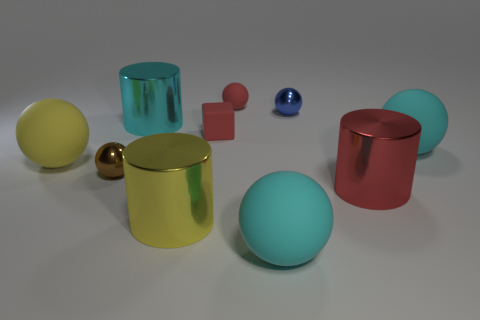What material is the cylinder that is the same color as the tiny matte ball?
Provide a short and direct response. Metal. There is a metal sphere that is right of the tiny shiny thing that is on the left side of the big matte ball that is in front of the large yellow rubber ball; what size is it?
Your response must be concise. Small. What number of blue cubes have the same material as the small brown thing?
Provide a short and direct response. 0. Are there fewer small cubes than cyan objects?
Your response must be concise. Yes. There is a blue metal object that is the same shape as the big yellow rubber thing; what is its size?
Provide a succinct answer. Small. Is the material of the tiny red thing that is behind the large cyan metallic object the same as the big red cylinder?
Provide a succinct answer. No. Does the blue object have the same shape as the yellow rubber thing?
Your response must be concise. Yes. How many things are either tiny objects that are behind the big yellow rubber sphere or large purple things?
Keep it short and to the point. 3. There is a brown object that is the same material as the big red object; what is its size?
Offer a very short reply. Small. What number of other tiny rubber blocks have the same color as the block?
Give a very brief answer. 0. 